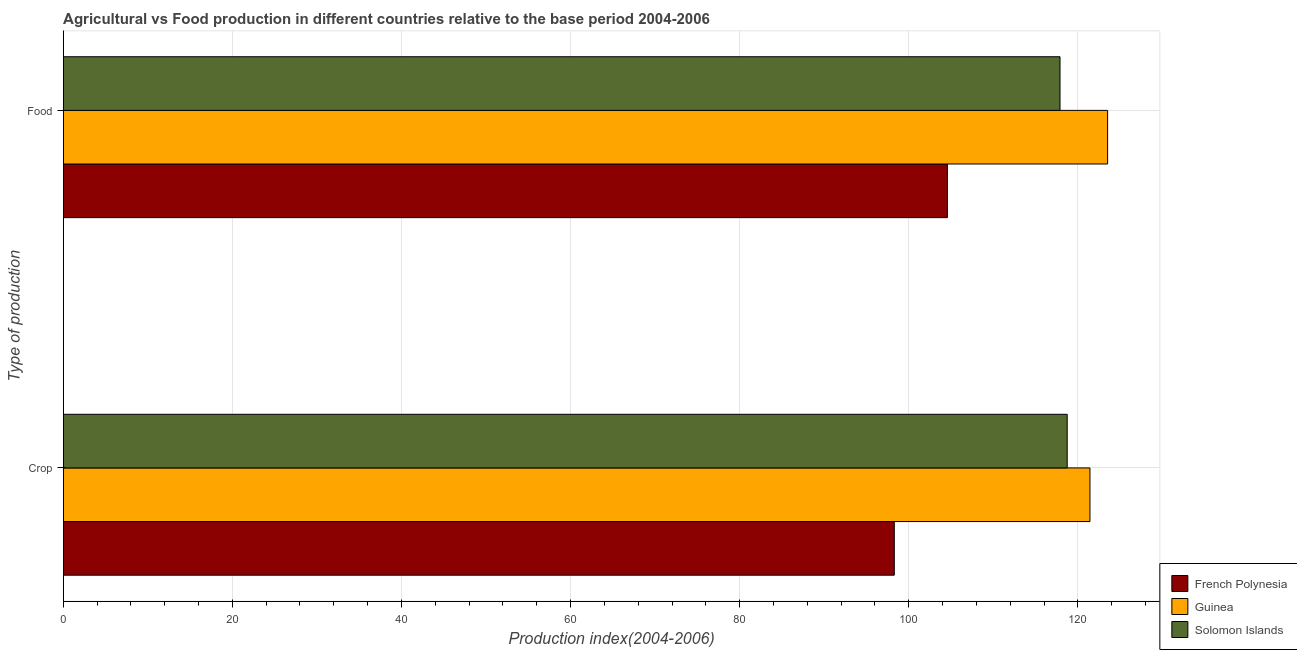How many different coloured bars are there?
Offer a very short reply. 3. How many bars are there on the 1st tick from the top?
Your answer should be very brief. 3. How many bars are there on the 1st tick from the bottom?
Your response must be concise. 3. What is the label of the 1st group of bars from the top?
Your answer should be very brief. Food. What is the crop production index in Guinea?
Offer a very short reply. 121.43. Across all countries, what is the maximum food production index?
Offer a very short reply. 123.52. Across all countries, what is the minimum crop production index?
Your response must be concise. 98.29. In which country was the food production index maximum?
Your response must be concise. Guinea. In which country was the crop production index minimum?
Your response must be concise. French Polynesia. What is the total crop production index in the graph?
Make the answer very short. 338.46. What is the difference between the food production index in French Polynesia and that in Guinea?
Give a very brief answer. -18.95. What is the difference between the food production index in French Polynesia and the crop production index in Guinea?
Make the answer very short. -16.86. What is the average crop production index per country?
Offer a very short reply. 112.82. What is the difference between the food production index and crop production index in Guinea?
Keep it short and to the point. 2.09. In how many countries, is the crop production index greater than 100 ?
Your answer should be very brief. 2. What is the ratio of the crop production index in Solomon Islands to that in French Polynesia?
Your answer should be very brief. 1.21. Is the food production index in Solomon Islands less than that in French Polynesia?
Ensure brevity in your answer.  No. What does the 2nd bar from the top in Crop represents?
Your response must be concise. Guinea. What does the 3rd bar from the bottom in Food represents?
Your answer should be compact. Solomon Islands. How many bars are there?
Keep it short and to the point. 6. Are all the bars in the graph horizontal?
Make the answer very short. Yes. What is the difference between two consecutive major ticks on the X-axis?
Your answer should be very brief. 20. Does the graph contain any zero values?
Your response must be concise. No. Does the graph contain grids?
Offer a very short reply. Yes. Where does the legend appear in the graph?
Your answer should be compact. Bottom right. How are the legend labels stacked?
Offer a terse response. Vertical. What is the title of the graph?
Your response must be concise. Agricultural vs Food production in different countries relative to the base period 2004-2006. What is the label or title of the X-axis?
Your response must be concise. Production index(2004-2006). What is the label or title of the Y-axis?
Keep it short and to the point. Type of production. What is the Production index(2004-2006) of French Polynesia in Crop?
Offer a terse response. 98.29. What is the Production index(2004-2006) of Guinea in Crop?
Your answer should be compact. 121.43. What is the Production index(2004-2006) in Solomon Islands in Crop?
Offer a very short reply. 118.74. What is the Production index(2004-2006) of French Polynesia in Food?
Keep it short and to the point. 104.57. What is the Production index(2004-2006) of Guinea in Food?
Provide a succinct answer. 123.52. What is the Production index(2004-2006) of Solomon Islands in Food?
Make the answer very short. 117.89. Across all Type of production, what is the maximum Production index(2004-2006) of French Polynesia?
Make the answer very short. 104.57. Across all Type of production, what is the maximum Production index(2004-2006) in Guinea?
Your answer should be compact. 123.52. Across all Type of production, what is the maximum Production index(2004-2006) of Solomon Islands?
Your answer should be compact. 118.74. Across all Type of production, what is the minimum Production index(2004-2006) in French Polynesia?
Your response must be concise. 98.29. Across all Type of production, what is the minimum Production index(2004-2006) of Guinea?
Ensure brevity in your answer.  121.43. Across all Type of production, what is the minimum Production index(2004-2006) of Solomon Islands?
Your response must be concise. 117.89. What is the total Production index(2004-2006) in French Polynesia in the graph?
Your answer should be very brief. 202.86. What is the total Production index(2004-2006) of Guinea in the graph?
Ensure brevity in your answer.  244.95. What is the total Production index(2004-2006) of Solomon Islands in the graph?
Your response must be concise. 236.63. What is the difference between the Production index(2004-2006) of French Polynesia in Crop and that in Food?
Offer a very short reply. -6.28. What is the difference between the Production index(2004-2006) in Guinea in Crop and that in Food?
Ensure brevity in your answer.  -2.09. What is the difference between the Production index(2004-2006) in French Polynesia in Crop and the Production index(2004-2006) in Guinea in Food?
Make the answer very short. -25.23. What is the difference between the Production index(2004-2006) in French Polynesia in Crop and the Production index(2004-2006) in Solomon Islands in Food?
Offer a terse response. -19.6. What is the difference between the Production index(2004-2006) in Guinea in Crop and the Production index(2004-2006) in Solomon Islands in Food?
Provide a succinct answer. 3.54. What is the average Production index(2004-2006) of French Polynesia per Type of production?
Provide a succinct answer. 101.43. What is the average Production index(2004-2006) in Guinea per Type of production?
Offer a very short reply. 122.47. What is the average Production index(2004-2006) of Solomon Islands per Type of production?
Ensure brevity in your answer.  118.31. What is the difference between the Production index(2004-2006) in French Polynesia and Production index(2004-2006) in Guinea in Crop?
Offer a terse response. -23.14. What is the difference between the Production index(2004-2006) in French Polynesia and Production index(2004-2006) in Solomon Islands in Crop?
Offer a very short reply. -20.45. What is the difference between the Production index(2004-2006) in Guinea and Production index(2004-2006) in Solomon Islands in Crop?
Provide a succinct answer. 2.69. What is the difference between the Production index(2004-2006) of French Polynesia and Production index(2004-2006) of Guinea in Food?
Your answer should be compact. -18.95. What is the difference between the Production index(2004-2006) of French Polynesia and Production index(2004-2006) of Solomon Islands in Food?
Your answer should be very brief. -13.32. What is the difference between the Production index(2004-2006) of Guinea and Production index(2004-2006) of Solomon Islands in Food?
Make the answer very short. 5.63. What is the ratio of the Production index(2004-2006) of French Polynesia in Crop to that in Food?
Keep it short and to the point. 0.94. What is the ratio of the Production index(2004-2006) in Guinea in Crop to that in Food?
Give a very brief answer. 0.98. What is the difference between the highest and the second highest Production index(2004-2006) of French Polynesia?
Offer a terse response. 6.28. What is the difference between the highest and the second highest Production index(2004-2006) in Guinea?
Your answer should be very brief. 2.09. What is the difference between the highest and the second highest Production index(2004-2006) of Solomon Islands?
Offer a very short reply. 0.85. What is the difference between the highest and the lowest Production index(2004-2006) in French Polynesia?
Give a very brief answer. 6.28. What is the difference between the highest and the lowest Production index(2004-2006) of Guinea?
Offer a terse response. 2.09. What is the difference between the highest and the lowest Production index(2004-2006) of Solomon Islands?
Keep it short and to the point. 0.85. 